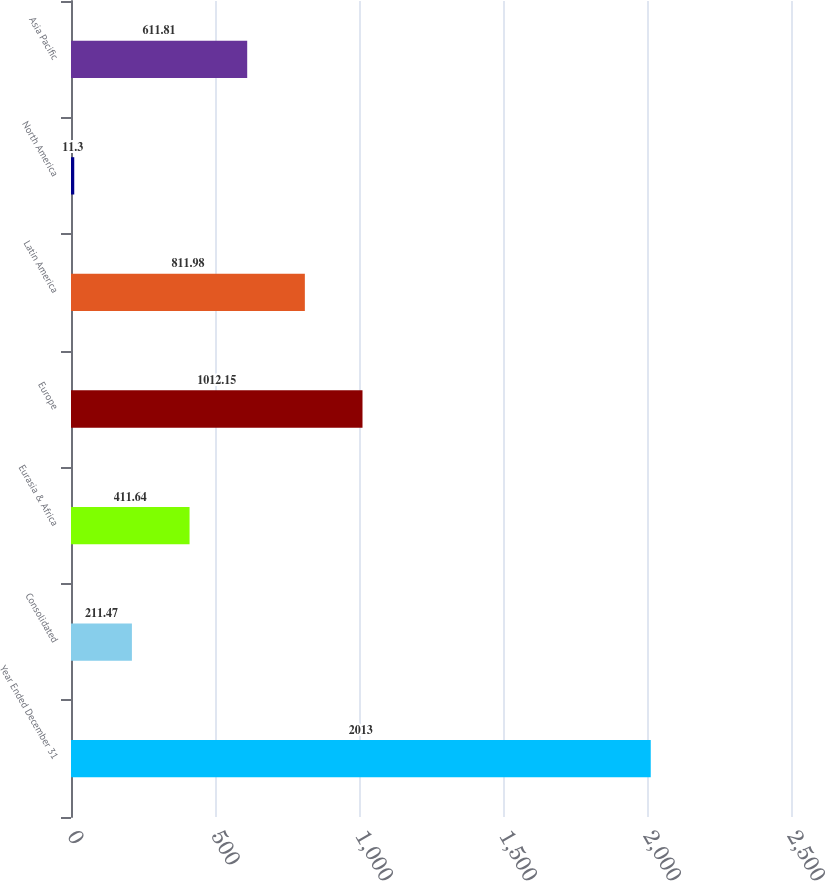<chart> <loc_0><loc_0><loc_500><loc_500><bar_chart><fcel>Year Ended December 31<fcel>Consolidated<fcel>Eurasia & Africa<fcel>Europe<fcel>Latin America<fcel>North America<fcel>Asia Pacific<nl><fcel>2013<fcel>211.47<fcel>411.64<fcel>1012.15<fcel>811.98<fcel>11.3<fcel>611.81<nl></chart> 